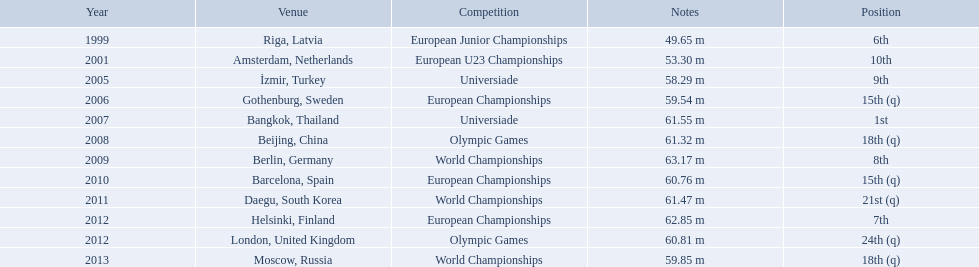What are the years that gerhard mayer participated? 1999, 2001, 2005, 2006, 2007, 2008, 2009, 2010, 2011, 2012, 2012, 2013. Which years were earlier than 2007? 1999, 2001, 2005, 2006. What was the best placing for these years? 6th. 